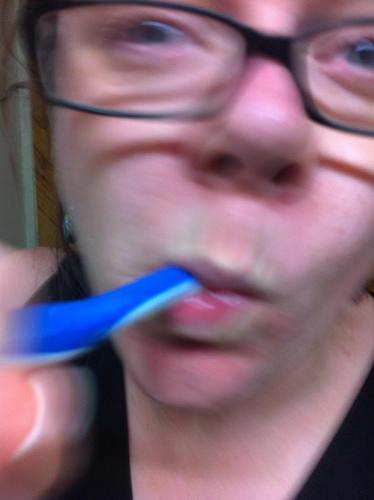How many people are in this photo?
Give a very brief answer. 1. 